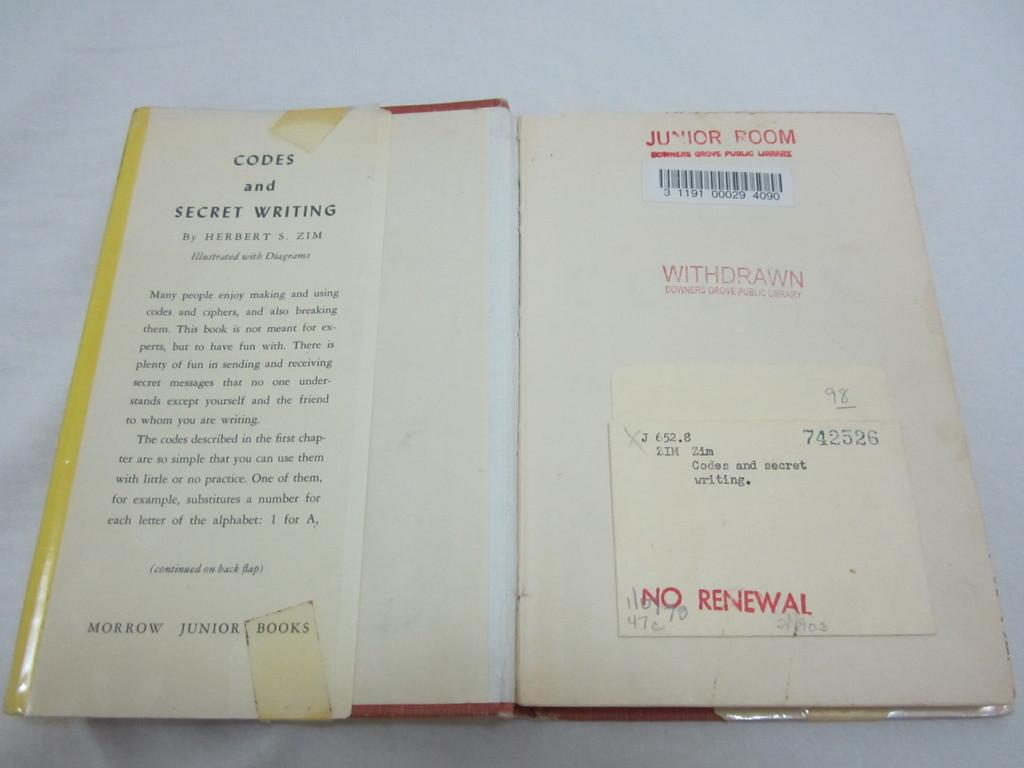<image>
Offer a succinct explanation of the picture presented. a book that says 'junior room' at the top of it and 'withdrawn' in the middle of it 